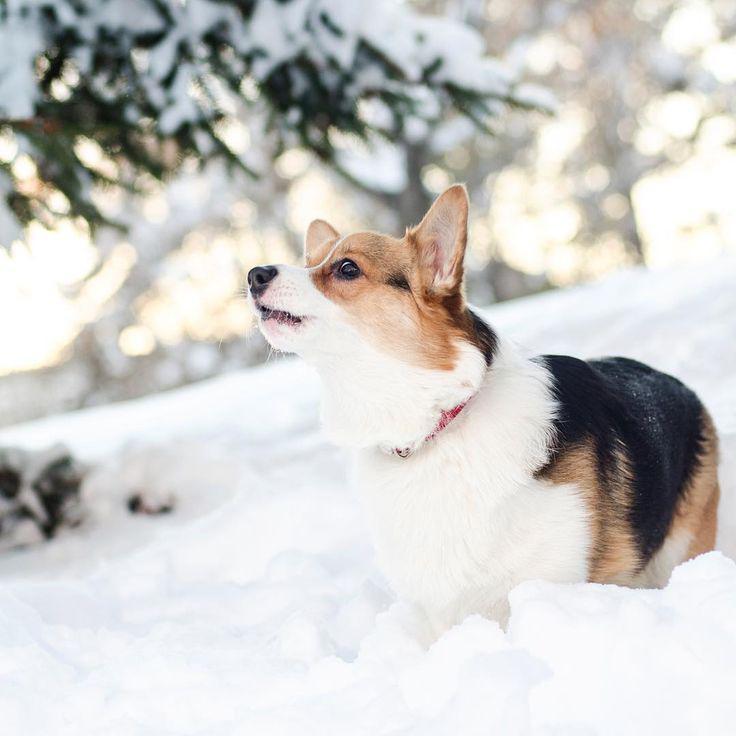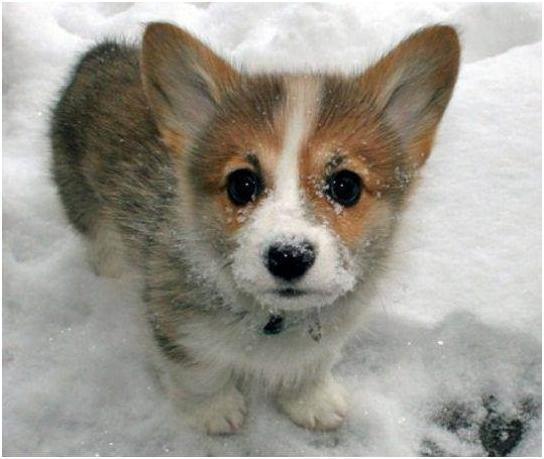The first image is the image on the left, the second image is the image on the right. Analyze the images presented: Is the assertion "There are three dogs in the image pair." valid? Answer yes or no. No. The first image is the image on the left, the second image is the image on the right. Given the left and right images, does the statement "There are exactly 3 dogs." hold true? Answer yes or no. No. 